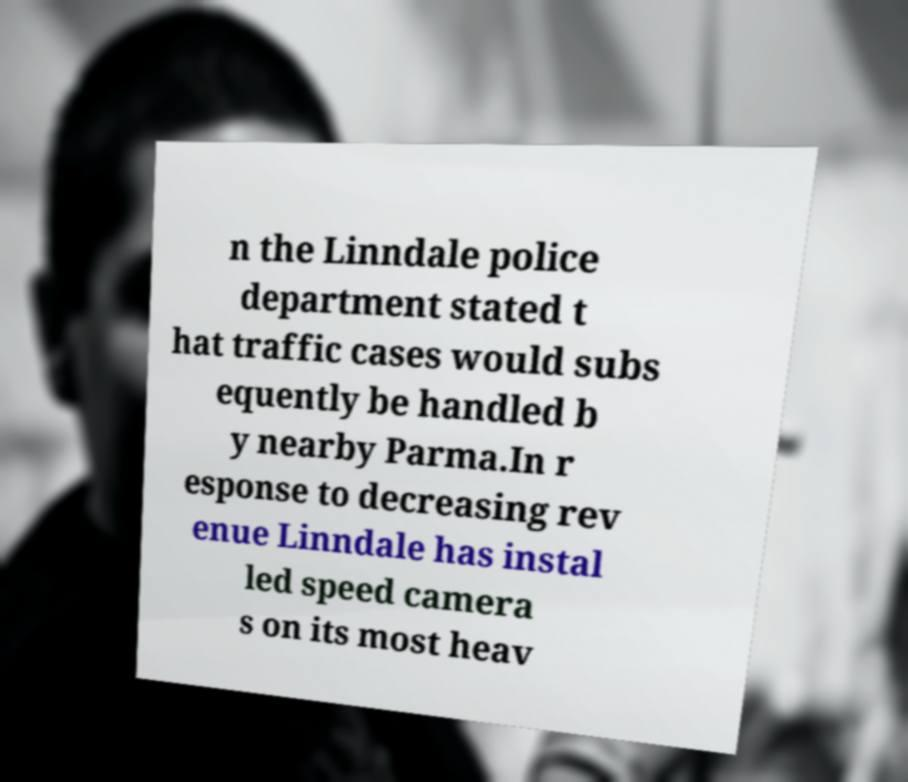For documentation purposes, I need the text within this image transcribed. Could you provide that? n the Linndale police department stated t hat traffic cases would subs equently be handled b y nearby Parma.In r esponse to decreasing rev enue Linndale has instal led speed camera s on its most heav 